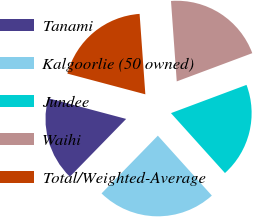<chart> <loc_0><loc_0><loc_500><loc_500><pie_chart><fcel>Tanami<fcel>Kalgoorlie (50 owned)<fcel>Jundee<fcel>Waihi<fcel>Total/Weighted-Average<nl><fcel>16.84%<fcel>23.97%<fcel>19.02%<fcel>20.44%<fcel>19.73%<nl></chart> 